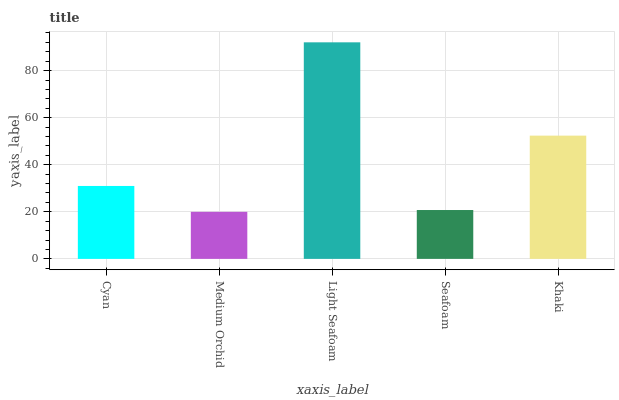Is Medium Orchid the minimum?
Answer yes or no. Yes. Is Light Seafoam the maximum?
Answer yes or no. Yes. Is Light Seafoam the minimum?
Answer yes or no. No. Is Medium Orchid the maximum?
Answer yes or no. No. Is Light Seafoam greater than Medium Orchid?
Answer yes or no. Yes. Is Medium Orchid less than Light Seafoam?
Answer yes or no. Yes. Is Medium Orchid greater than Light Seafoam?
Answer yes or no. No. Is Light Seafoam less than Medium Orchid?
Answer yes or no. No. Is Cyan the high median?
Answer yes or no. Yes. Is Cyan the low median?
Answer yes or no. Yes. Is Khaki the high median?
Answer yes or no. No. Is Khaki the low median?
Answer yes or no. No. 